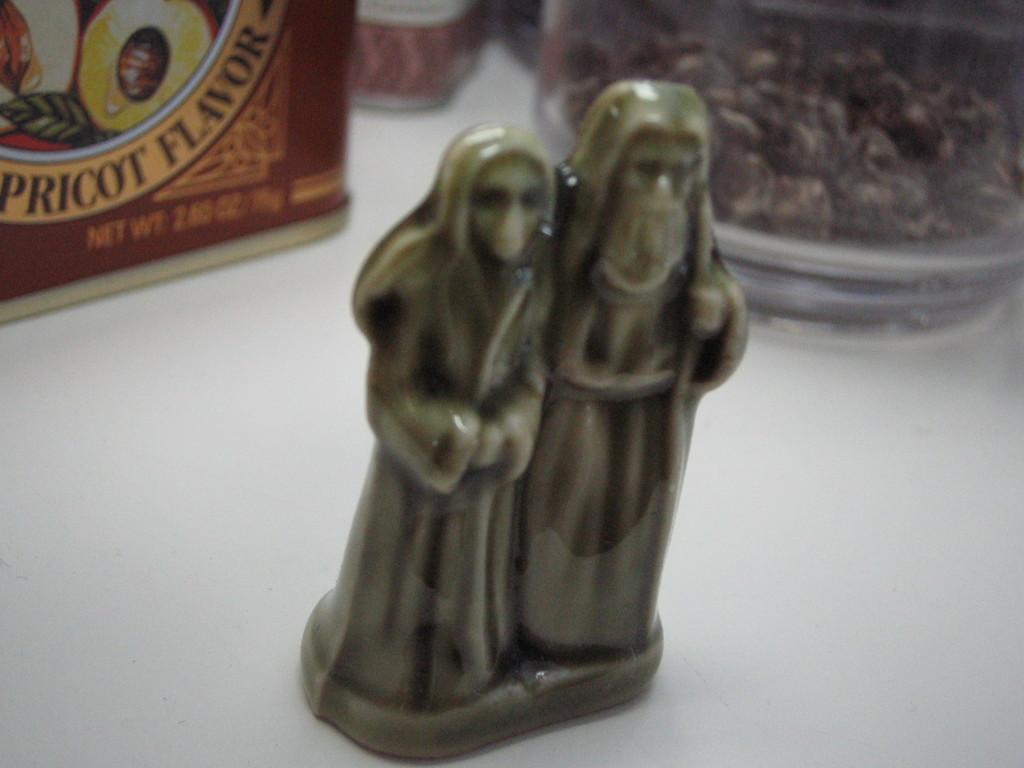Please provide a concise description of this image. In the image there is statue of two humans on a table with food bowls behind it. 